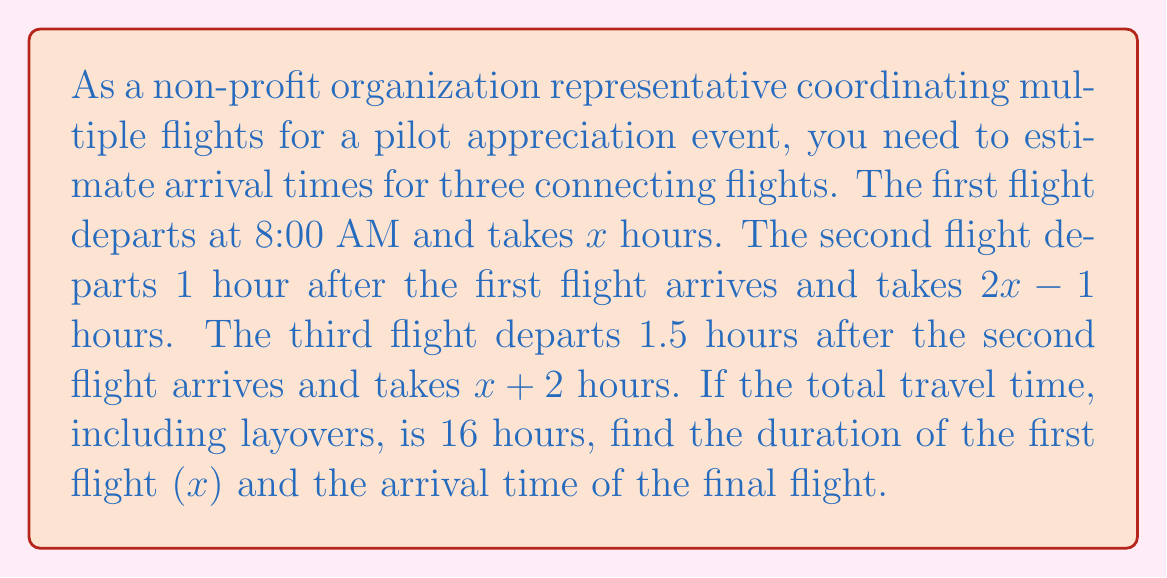Show me your answer to this math problem. Let's solve this problem step by step:

1) First, let's set up an equation for the total travel time:
   $$x + 1 + (2x - 1) + 1.5 + (x + 2) = 16$$

2) Simplify the left side of the equation:
   $$4x + 3.5 = 16$$

3) Subtract 3.5 from both sides:
   $$4x = 12.5$$

4) Divide both sides by 4:
   $$x = 3.125$$

5) Now that we know $x$, we can calculate the duration of each flight:
   - First flight: $x = 3.125$ hours
   - Second flight: $2x - 1 = 2(3.125) - 1 = 5.25$ hours
   - Third flight: $x + 2 = 3.125 + 2 = 5.125$ hours

6) Let's calculate the arrival time of each flight:
   - First flight: 8:00 AM + 3.125 hours = 11:07 AM
   - Second flight departs at 12:07 PM and arrives at 5:22 PM
   - Third flight departs at 6:52 PM and arrives at 12:00 AM (midnight)

Therefore, the duration of the first flight is 3.125 hours, and the final flight arrives at 12:00 AM (midnight).
Answer: $x = 3.125$ hours; Final arrival: 12:00 AM 